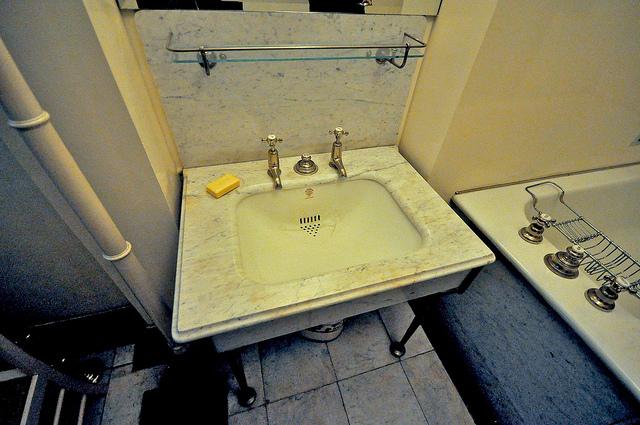Is this room esthetically pleasing?
Be succinct. No. Is the sink clean?
Keep it brief. Yes. Is the tap running?
Answer briefly. No. 